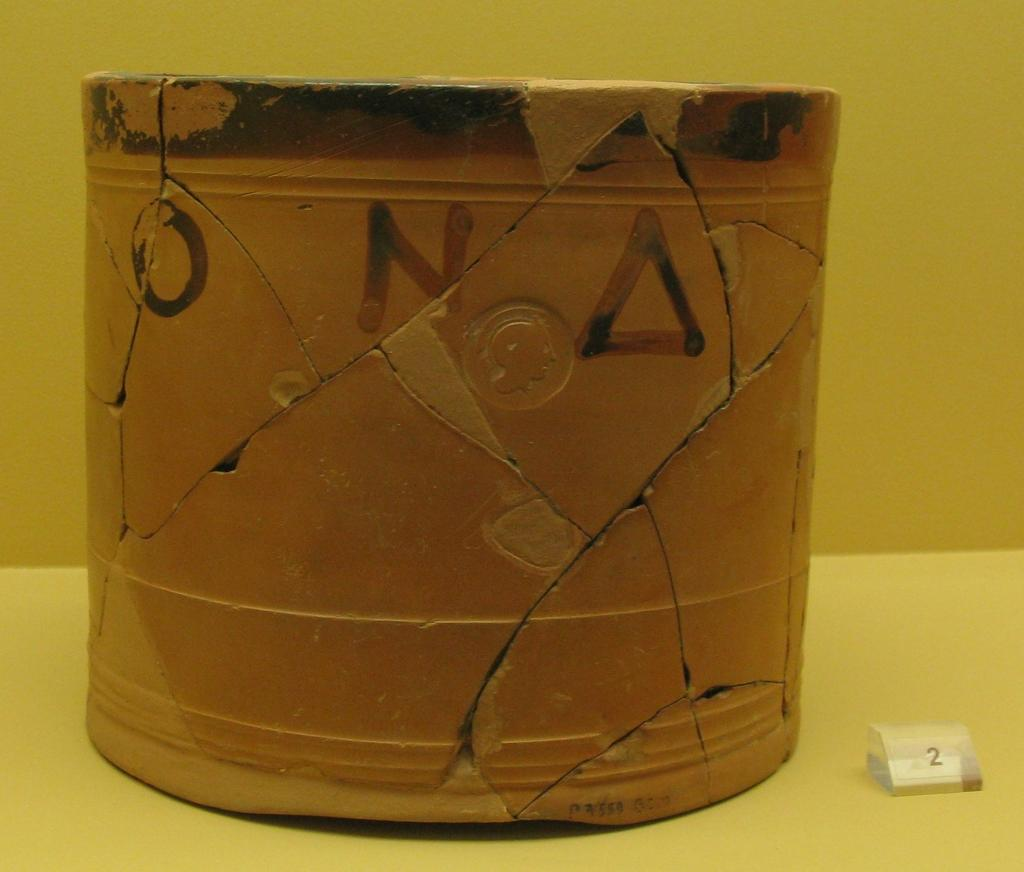<image>
Offer a succinct explanation of the picture presented. A cracked clay pot with "O", "N", and a triangle painted on it that has been glued back together. 